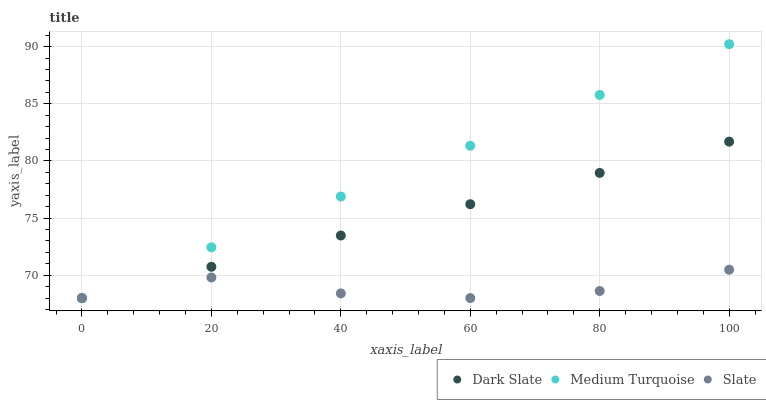Does Slate have the minimum area under the curve?
Answer yes or no. Yes. Does Medium Turquoise have the maximum area under the curve?
Answer yes or no. Yes. Does Medium Turquoise have the minimum area under the curve?
Answer yes or no. No. Does Slate have the maximum area under the curve?
Answer yes or no. No. Is Dark Slate the smoothest?
Answer yes or no. Yes. Is Slate the roughest?
Answer yes or no. Yes. Is Medium Turquoise the smoothest?
Answer yes or no. No. Is Medium Turquoise the roughest?
Answer yes or no. No. Does Dark Slate have the lowest value?
Answer yes or no. Yes. Does Medium Turquoise have the highest value?
Answer yes or no. Yes. Does Slate have the highest value?
Answer yes or no. No. Does Dark Slate intersect Medium Turquoise?
Answer yes or no. Yes. Is Dark Slate less than Medium Turquoise?
Answer yes or no. No. Is Dark Slate greater than Medium Turquoise?
Answer yes or no. No. 